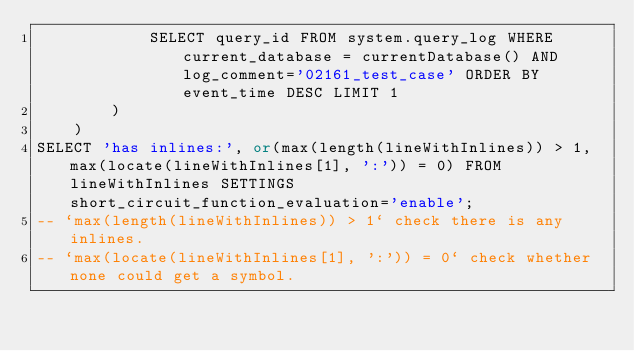<code> <loc_0><loc_0><loc_500><loc_500><_SQL_>            SELECT query_id FROM system.query_log WHERE current_database = currentDatabase() AND log_comment='02161_test_case' ORDER BY event_time DESC LIMIT 1
        )
    )
SELECT 'has inlines:', or(max(length(lineWithInlines)) > 1, max(locate(lineWithInlines[1], ':')) = 0) FROM lineWithInlines SETTINGS short_circuit_function_evaluation='enable';
-- `max(length(lineWithInlines)) > 1` check there is any inlines.
-- `max(locate(lineWithInlines[1], ':')) = 0` check whether none could get a symbol.
</code> 